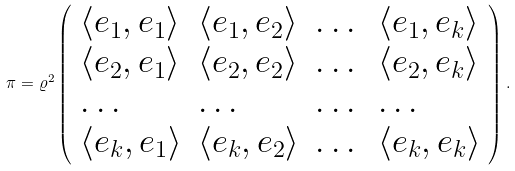Convert formula to latex. <formula><loc_0><loc_0><loc_500><loc_500>\pi = \varrho ^ { 2 } \left ( \begin{array} { l l l l } \langle e _ { 1 } , e _ { 1 } \rangle & \langle e _ { 1 } , e _ { 2 } \rangle & \dots & \langle e _ { 1 } , e _ { k } \rangle \\ \langle e _ { 2 } , e _ { 1 } \rangle & \langle e _ { 2 } , e _ { 2 } \rangle & \dots & \langle e _ { 2 } , e _ { k } \rangle \\ \dots & \dots & \dots & \dots \\ \langle e _ { k } , e _ { 1 } \rangle & \langle e _ { k } , e _ { 2 } \rangle & \dots & \langle e _ { k } , e _ { k } \rangle \end{array} \right ) .</formula> 